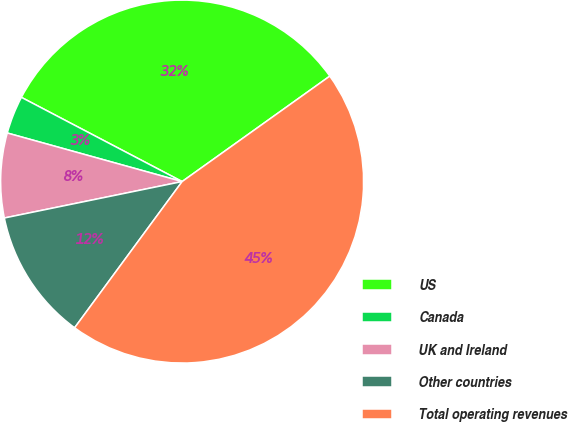Convert chart. <chart><loc_0><loc_0><loc_500><loc_500><pie_chart><fcel>US<fcel>Canada<fcel>UK and Ireland<fcel>Other countries<fcel>Total operating revenues<nl><fcel>32.45%<fcel>3.37%<fcel>7.53%<fcel>11.69%<fcel>44.96%<nl></chart> 